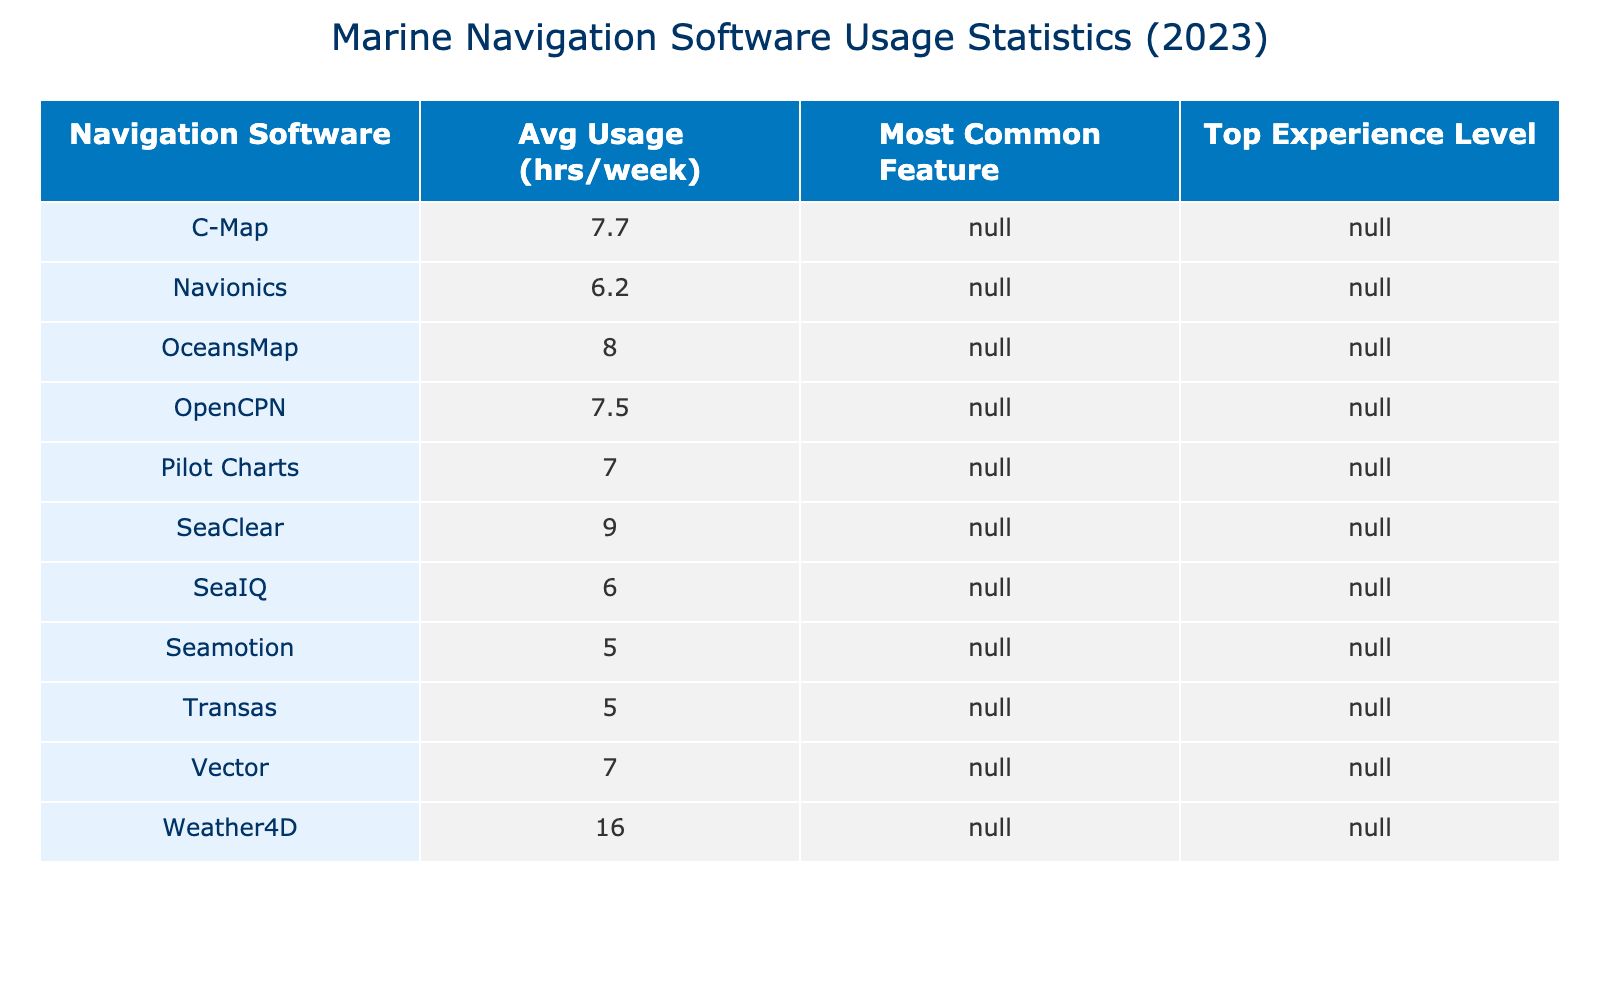What is the navigation software with the highest average usage hours per week? By reviewing the table, we look for the software with the highest value in the 'Avg Usage (hrs/week)' column. Weather4D has the highest average usage at 16 hours per week.
Answer: Weather4D Which navigation software has the most common feature of 'User community'? We need to find the software that lists 'User community' as the most common feature in the 'Most Common Feature' column. OpenCPN is the software that has 'User community' as its most common feature.
Answer: OpenCPN What is the average usage hours per week for Navionics users? To find this, we check the 'Avg Usage (hrs/week)' column for Navionics. The average for Navionics is 5 + 10 + 9 + 4 = 28 hours across 4 users, resulting in an average of 28/4 = 7 hours per week.
Answer: 7 Name the two navigation software that have 'Advanced' as the top experience level. We look in the 'Top Experience Level' column and identify software that has 'Advanced'. The navigation software with this level are C-Map and Weather4D.
Answer: C-Map, Weather4D Is there a navigation software with a user experience level of 'Beginner' that also has the preferred feature 'Real-time weather updates'? We check both the 'User Experience Level' and 'Preferred Features' columns. No software listed has 'Beginner' as the experience level with 'Real-time weather updates'.
Answer: No What is the total usage hours per week for all sailors using OpenCPN? We find all the users for OpenCPN in the 'Avg Usage (hrs/week)' column and sum their usage hours: 8 + 12 + 6 = 26 hours per week for OpenCPN users.
Answer: 26 Which software has the least average usage hours and what is that value? We check the 'Avg Usage (hrs/week)' column to find the smallest value. The least average usage is 3 hours per week from Navionics.
Answer: 3 How many navigation software options have 'Customizability' as a preferred feature? We count in the 'Most Common Feature' column for instances of 'Customizability'. It appears once in relation to OpenCPN only.
Answer: 1 